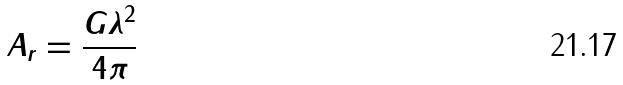<formula> <loc_0><loc_0><loc_500><loc_500>A _ { r } = \frac { G \lambda ^ { 2 } } { 4 \pi }</formula> 